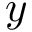Convert formula to latex. <formula><loc_0><loc_0><loc_500><loc_500>y</formula> 